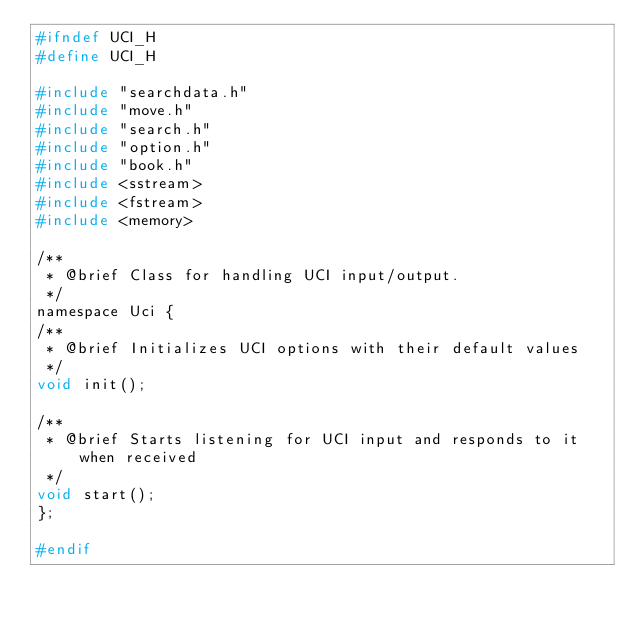Convert code to text. <code><loc_0><loc_0><loc_500><loc_500><_C_>#ifndef UCI_H
#define UCI_H

#include "searchdata.h"
#include "move.h"
#include "search.h"
#include "option.h"
#include "book.h"
#include <sstream>
#include <fstream>
#include <memory>

/**
 * @brief Class for handling UCI input/output.
 */
namespace Uci {
/**
 * @brief Initializes UCI options with their default values
 */
void init();

/**
 * @brief Starts listening for UCI input and responds to it when received
 */
void start();
};

#endif
</code> 